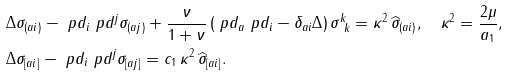Convert formula to latex. <formula><loc_0><loc_0><loc_500><loc_500>& \Delta \sigma _ { ( a i ) } - \ p d _ { i } \ p d ^ { j } \sigma _ { ( a j ) } + \frac { \nu } { 1 + \nu } \left ( \ p d _ { a } \ p d _ { i } - \delta _ { a i } \Delta \right ) \sigma ^ { k } _ { \ k } = \kappa ^ { 2 } \, \widehat { \sigma } _ { ( a i ) } , \quad \kappa ^ { 2 } = \frac { 2 \mu } { a _ { 1 } } , \\ & \Delta \sigma _ { [ a i ] } - \ p d _ { i } \ p d ^ { j } \sigma _ { [ a j ] } = c _ { 1 } \, \kappa ^ { 2 } \, \widehat { \sigma } _ { [ a i ] } .</formula> 